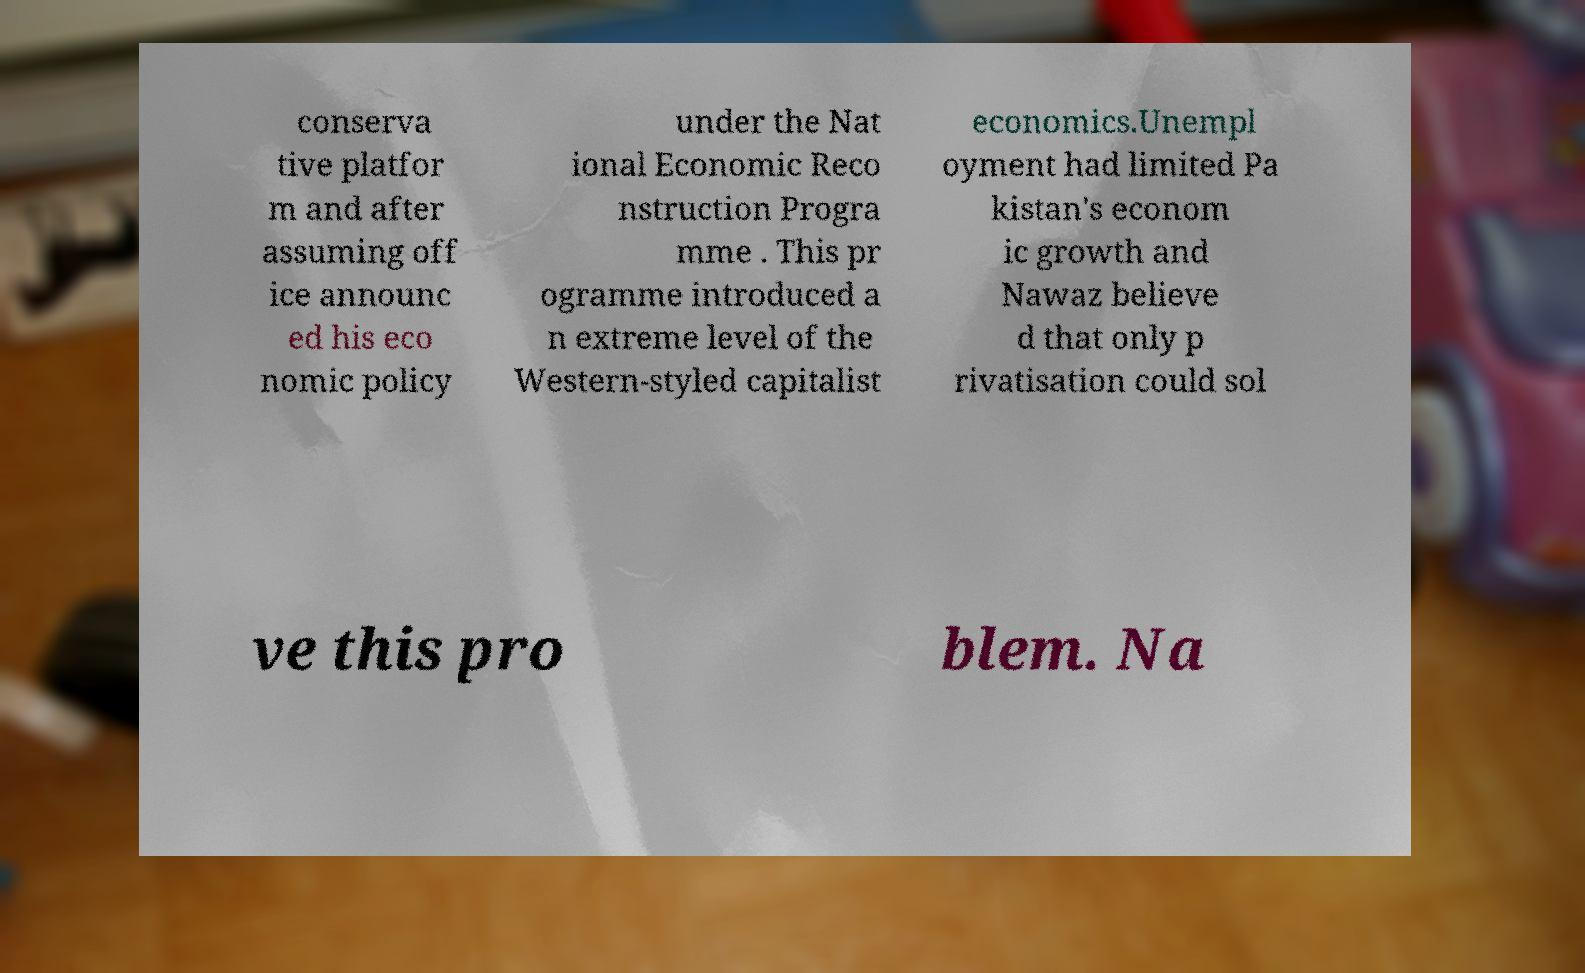Could you extract and type out the text from this image? conserva tive platfor m and after assuming off ice announc ed his eco nomic policy under the Nat ional Economic Reco nstruction Progra mme . This pr ogramme introduced a n extreme level of the Western-styled capitalist economics.Unempl oyment had limited Pa kistan's econom ic growth and Nawaz believe d that only p rivatisation could sol ve this pro blem. Na 